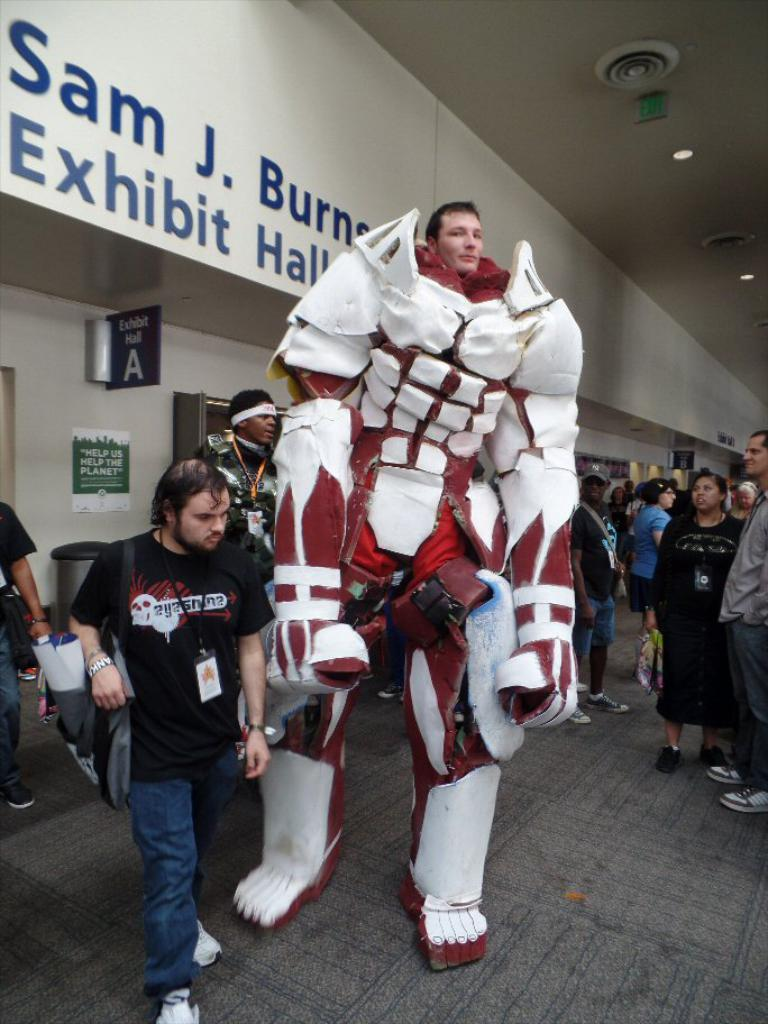What is the person in the image wearing? There is a person in a fancy dress in the image. Who else is present in the image? There is a group of people standing in the image. What objects can be seen in the image? There are boards and lights in the image. How many cattle are present in the image? There are no cattle present in the image. What type of trouble is the person in the fancy dress experiencing in the image? There is no indication of trouble in the image; the person is simply standing with a group of people. 